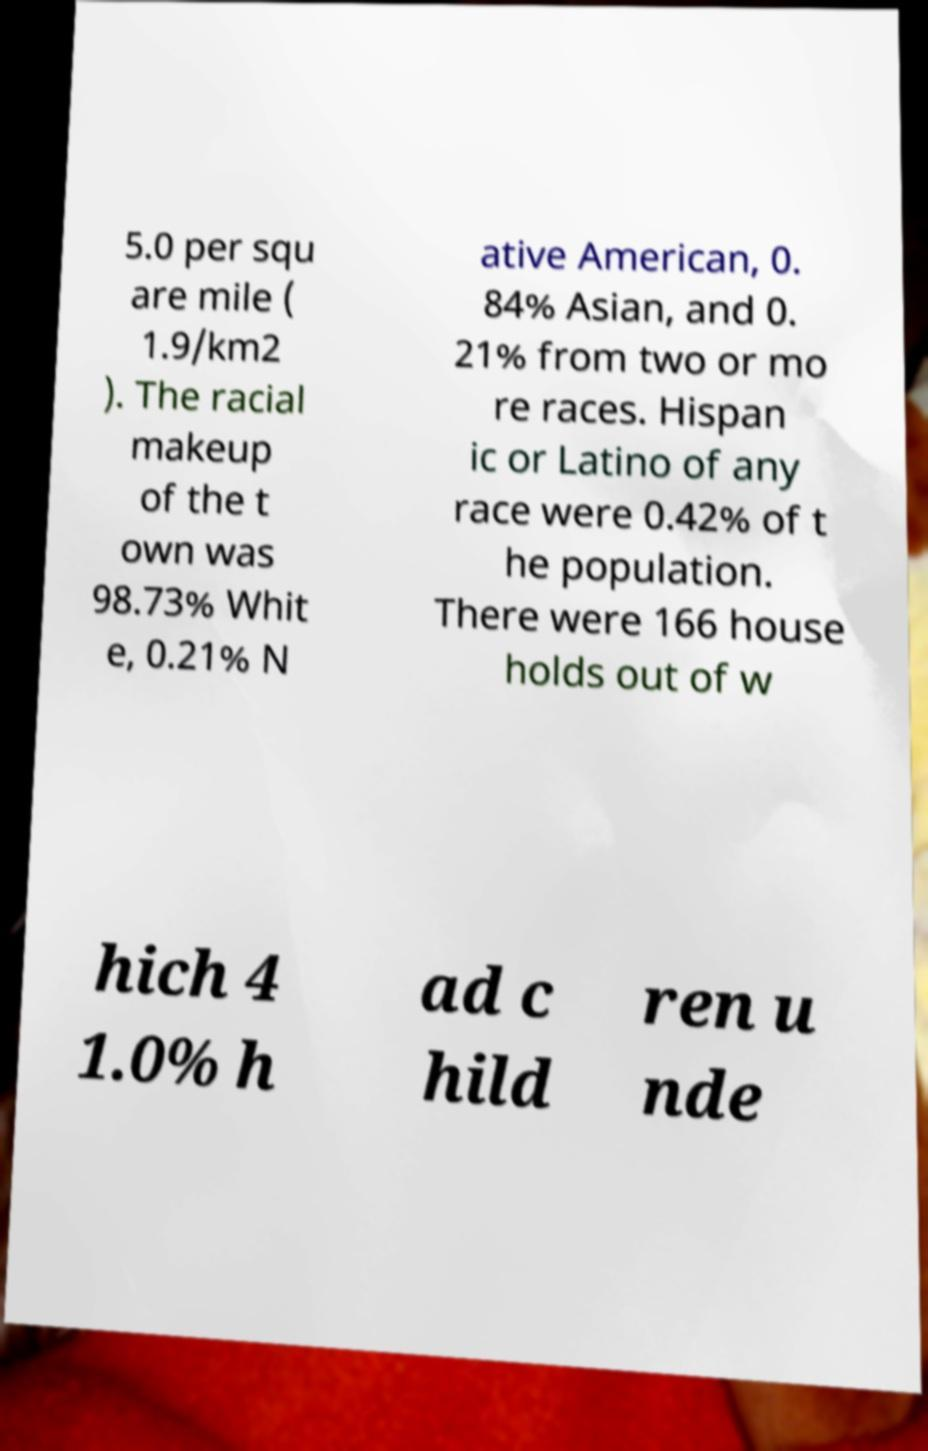Please identify and transcribe the text found in this image. 5.0 per squ are mile ( 1.9/km2 ). The racial makeup of the t own was 98.73% Whit e, 0.21% N ative American, 0. 84% Asian, and 0. 21% from two or mo re races. Hispan ic or Latino of any race were 0.42% of t he population. There were 166 house holds out of w hich 4 1.0% h ad c hild ren u nde 